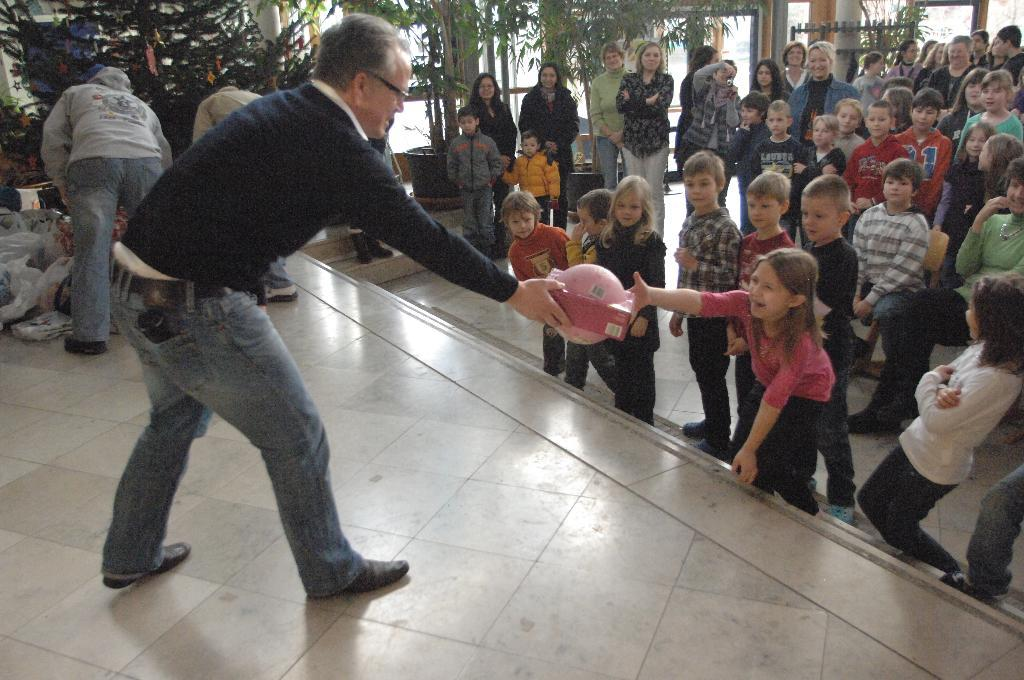What is the man on the left side of the image doing? The man is standing on the left side of the image and holding an object. Can you describe the people on the right side of the image? There are people standing on the right side of the image. What can be seen in the background of the image? In the background of the image, there are plants, doors, and covers. What type of eggs are being used to hold the flag in the image? There are no eggs or flags present in the image. 